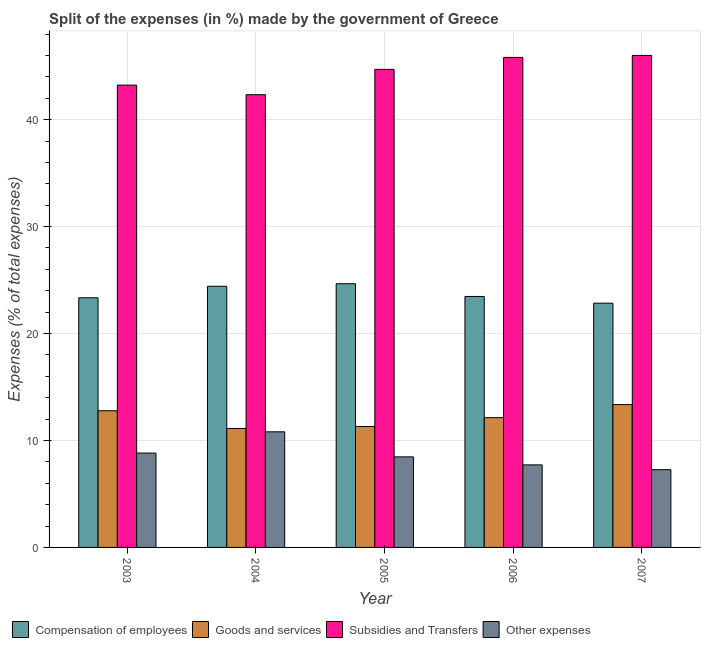How many different coloured bars are there?
Make the answer very short. 4. How many bars are there on the 5th tick from the left?
Make the answer very short. 4. How many bars are there on the 2nd tick from the right?
Offer a terse response. 4. What is the label of the 3rd group of bars from the left?
Your answer should be very brief. 2005. In how many cases, is the number of bars for a given year not equal to the number of legend labels?
Your answer should be compact. 0. What is the percentage of amount spent on goods and services in 2004?
Offer a very short reply. 11.12. Across all years, what is the maximum percentage of amount spent on compensation of employees?
Your answer should be very brief. 24.66. Across all years, what is the minimum percentage of amount spent on subsidies?
Ensure brevity in your answer.  42.33. What is the total percentage of amount spent on goods and services in the graph?
Offer a terse response. 60.7. What is the difference between the percentage of amount spent on goods and services in 2006 and that in 2007?
Provide a succinct answer. -1.22. What is the difference between the percentage of amount spent on other expenses in 2004 and the percentage of amount spent on subsidies in 2006?
Your answer should be compact. 3.09. What is the average percentage of amount spent on subsidies per year?
Offer a terse response. 44.42. In the year 2006, what is the difference between the percentage of amount spent on compensation of employees and percentage of amount spent on other expenses?
Provide a short and direct response. 0. In how many years, is the percentage of amount spent on other expenses greater than 18 %?
Your response must be concise. 0. What is the ratio of the percentage of amount spent on subsidies in 2003 to that in 2004?
Your answer should be very brief. 1.02. What is the difference between the highest and the second highest percentage of amount spent on other expenses?
Provide a succinct answer. 1.99. What is the difference between the highest and the lowest percentage of amount spent on goods and services?
Your response must be concise. 2.23. In how many years, is the percentage of amount spent on compensation of employees greater than the average percentage of amount spent on compensation of employees taken over all years?
Offer a terse response. 2. Is the sum of the percentage of amount spent on subsidies in 2006 and 2007 greater than the maximum percentage of amount spent on other expenses across all years?
Offer a terse response. Yes. Is it the case that in every year, the sum of the percentage of amount spent on goods and services and percentage of amount spent on compensation of employees is greater than the sum of percentage of amount spent on other expenses and percentage of amount spent on subsidies?
Your response must be concise. No. What does the 2nd bar from the left in 2006 represents?
Provide a short and direct response. Goods and services. What does the 3rd bar from the right in 2004 represents?
Your answer should be very brief. Goods and services. Is it the case that in every year, the sum of the percentage of amount spent on compensation of employees and percentage of amount spent on goods and services is greater than the percentage of amount spent on subsidies?
Give a very brief answer. No. How many bars are there?
Your answer should be very brief. 20. Are the values on the major ticks of Y-axis written in scientific E-notation?
Your response must be concise. No. Does the graph contain any zero values?
Give a very brief answer. No. How many legend labels are there?
Provide a short and direct response. 4. How are the legend labels stacked?
Your response must be concise. Horizontal. What is the title of the graph?
Provide a short and direct response. Split of the expenses (in %) made by the government of Greece. Does "HFC gas" appear as one of the legend labels in the graph?
Your answer should be very brief. No. What is the label or title of the X-axis?
Give a very brief answer. Year. What is the label or title of the Y-axis?
Make the answer very short. Expenses (% of total expenses). What is the Expenses (% of total expenses) of Compensation of employees in 2003?
Provide a short and direct response. 23.34. What is the Expenses (% of total expenses) in Goods and services in 2003?
Keep it short and to the point. 12.78. What is the Expenses (% of total expenses) in Subsidies and Transfers in 2003?
Your answer should be very brief. 43.23. What is the Expenses (% of total expenses) of Other expenses in 2003?
Provide a succinct answer. 8.82. What is the Expenses (% of total expenses) in Compensation of employees in 2004?
Your response must be concise. 24.42. What is the Expenses (% of total expenses) in Goods and services in 2004?
Make the answer very short. 11.12. What is the Expenses (% of total expenses) in Subsidies and Transfers in 2004?
Keep it short and to the point. 42.33. What is the Expenses (% of total expenses) of Other expenses in 2004?
Provide a succinct answer. 10.81. What is the Expenses (% of total expenses) of Compensation of employees in 2005?
Your answer should be very brief. 24.66. What is the Expenses (% of total expenses) of Goods and services in 2005?
Provide a succinct answer. 11.31. What is the Expenses (% of total expenses) of Subsidies and Transfers in 2005?
Keep it short and to the point. 44.7. What is the Expenses (% of total expenses) in Other expenses in 2005?
Make the answer very short. 8.47. What is the Expenses (% of total expenses) of Compensation of employees in 2006?
Your response must be concise. 23.47. What is the Expenses (% of total expenses) in Goods and services in 2006?
Give a very brief answer. 12.13. What is the Expenses (% of total expenses) in Subsidies and Transfers in 2006?
Offer a terse response. 45.82. What is the Expenses (% of total expenses) of Other expenses in 2006?
Provide a short and direct response. 7.72. What is the Expenses (% of total expenses) in Compensation of employees in 2007?
Your response must be concise. 22.84. What is the Expenses (% of total expenses) of Goods and services in 2007?
Offer a terse response. 13.36. What is the Expenses (% of total expenses) of Subsidies and Transfers in 2007?
Ensure brevity in your answer.  46. What is the Expenses (% of total expenses) in Other expenses in 2007?
Offer a very short reply. 7.27. Across all years, what is the maximum Expenses (% of total expenses) of Compensation of employees?
Keep it short and to the point. 24.66. Across all years, what is the maximum Expenses (% of total expenses) of Goods and services?
Provide a succinct answer. 13.36. Across all years, what is the maximum Expenses (% of total expenses) in Subsidies and Transfers?
Keep it short and to the point. 46. Across all years, what is the maximum Expenses (% of total expenses) in Other expenses?
Offer a very short reply. 10.81. Across all years, what is the minimum Expenses (% of total expenses) in Compensation of employees?
Provide a short and direct response. 22.84. Across all years, what is the minimum Expenses (% of total expenses) in Goods and services?
Your answer should be compact. 11.12. Across all years, what is the minimum Expenses (% of total expenses) of Subsidies and Transfers?
Provide a succinct answer. 42.33. Across all years, what is the minimum Expenses (% of total expenses) of Other expenses?
Ensure brevity in your answer.  7.27. What is the total Expenses (% of total expenses) of Compensation of employees in the graph?
Provide a short and direct response. 118.73. What is the total Expenses (% of total expenses) in Goods and services in the graph?
Provide a short and direct response. 60.7. What is the total Expenses (% of total expenses) in Subsidies and Transfers in the graph?
Provide a succinct answer. 222.09. What is the total Expenses (% of total expenses) of Other expenses in the graph?
Your answer should be very brief. 43.09. What is the difference between the Expenses (% of total expenses) of Compensation of employees in 2003 and that in 2004?
Give a very brief answer. -1.08. What is the difference between the Expenses (% of total expenses) of Goods and services in 2003 and that in 2004?
Give a very brief answer. 1.66. What is the difference between the Expenses (% of total expenses) of Subsidies and Transfers in 2003 and that in 2004?
Your answer should be very brief. 0.9. What is the difference between the Expenses (% of total expenses) of Other expenses in 2003 and that in 2004?
Offer a terse response. -1.99. What is the difference between the Expenses (% of total expenses) in Compensation of employees in 2003 and that in 2005?
Keep it short and to the point. -1.31. What is the difference between the Expenses (% of total expenses) in Goods and services in 2003 and that in 2005?
Give a very brief answer. 1.47. What is the difference between the Expenses (% of total expenses) of Subsidies and Transfers in 2003 and that in 2005?
Your response must be concise. -1.47. What is the difference between the Expenses (% of total expenses) of Other expenses in 2003 and that in 2005?
Ensure brevity in your answer.  0.35. What is the difference between the Expenses (% of total expenses) in Compensation of employees in 2003 and that in 2006?
Offer a very short reply. -0.12. What is the difference between the Expenses (% of total expenses) in Goods and services in 2003 and that in 2006?
Make the answer very short. 0.65. What is the difference between the Expenses (% of total expenses) of Subsidies and Transfers in 2003 and that in 2006?
Your answer should be compact. -2.59. What is the difference between the Expenses (% of total expenses) of Other expenses in 2003 and that in 2006?
Give a very brief answer. 1.1. What is the difference between the Expenses (% of total expenses) of Compensation of employees in 2003 and that in 2007?
Make the answer very short. 0.5. What is the difference between the Expenses (% of total expenses) in Goods and services in 2003 and that in 2007?
Provide a succinct answer. -0.58. What is the difference between the Expenses (% of total expenses) in Subsidies and Transfers in 2003 and that in 2007?
Ensure brevity in your answer.  -2.78. What is the difference between the Expenses (% of total expenses) of Other expenses in 2003 and that in 2007?
Your response must be concise. 1.55. What is the difference between the Expenses (% of total expenses) in Compensation of employees in 2004 and that in 2005?
Your response must be concise. -0.24. What is the difference between the Expenses (% of total expenses) in Goods and services in 2004 and that in 2005?
Make the answer very short. -0.18. What is the difference between the Expenses (% of total expenses) in Subsidies and Transfers in 2004 and that in 2005?
Give a very brief answer. -2.37. What is the difference between the Expenses (% of total expenses) of Other expenses in 2004 and that in 2005?
Keep it short and to the point. 2.34. What is the difference between the Expenses (% of total expenses) of Compensation of employees in 2004 and that in 2006?
Offer a very short reply. 0.95. What is the difference between the Expenses (% of total expenses) in Goods and services in 2004 and that in 2006?
Offer a very short reply. -1.01. What is the difference between the Expenses (% of total expenses) of Subsidies and Transfers in 2004 and that in 2006?
Keep it short and to the point. -3.49. What is the difference between the Expenses (% of total expenses) in Other expenses in 2004 and that in 2006?
Give a very brief answer. 3.09. What is the difference between the Expenses (% of total expenses) of Compensation of employees in 2004 and that in 2007?
Your response must be concise. 1.58. What is the difference between the Expenses (% of total expenses) in Goods and services in 2004 and that in 2007?
Your response must be concise. -2.23. What is the difference between the Expenses (% of total expenses) of Subsidies and Transfers in 2004 and that in 2007?
Make the answer very short. -3.67. What is the difference between the Expenses (% of total expenses) of Other expenses in 2004 and that in 2007?
Offer a very short reply. 3.54. What is the difference between the Expenses (% of total expenses) of Compensation of employees in 2005 and that in 2006?
Keep it short and to the point. 1.19. What is the difference between the Expenses (% of total expenses) in Goods and services in 2005 and that in 2006?
Provide a short and direct response. -0.83. What is the difference between the Expenses (% of total expenses) in Subsidies and Transfers in 2005 and that in 2006?
Your answer should be very brief. -1.12. What is the difference between the Expenses (% of total expenses) in Other expenses in 2005 and that in 2006?
Your response must be concise. 0.75. What is the difference between the Expenses (% of total expenses) in Compensation of employees in 2005 and that in 2007?
Your answer should be very brief. 1.82. What is the difference between the Expenses (% of total expenses) of Goods and services in 2005 and that in 2007?
Your response must be concise. -2.05. What is the difference between the Expenses (% of total expenses) in Subsidies and Transfers in 2005 and that in 2007?
Offer a very short reply. -1.3. What is the difference between the Expenses (% of total expenses) of Other expenses in 2005 and that in 2007?
Your answer should be compact. 1.2. What is the difference between the Expenses (% of total expenses) in Compensation of employees in 2006 and that in 2007?
Give a very brief answer. 0.63. What is the difference between the Expenses (% of total expenses) of Goods and services in 2006 and that in 2007?
Provide a succinct answer. -1.22. What is the difference between the Expenses (% of total expenses) in Subsidies and Transfers in 2006 and that in 2007?
Ensure brevity in your answer.  -0.19. What is the difference between the Expenses (% of total expenses) of Other expenses in 2006 and that in 2007?
Make the answer very short. 0.45. What is the difference between the Expenses (% of total expenses) of Compensation of employees in 2003 and the Expenses (% of total expenses) of Goods and services in 2004?
Offer a very short reply. 12.22. What is the difference between the Expenses (% of total expenses) of Compensation of employees in 2003 and the Expenses (% of total expenses) of Subsidies and Transfers in 2004?
Give a very brief answer. -18.99. What is the difference between the Expenses (% of total expenses) in Compensation of employees in 2003 and the Expenses (% of total expenses) in Other expenses in 2004?
Offer a very short reply. 12.53. What is the difference between the Expenses (% of total expenses) in Goods and services in 2003 and the Expenses (% of total expenses) in Subsidies and Transfers in 2004?
Offer a terse response. -29.55. What is the difference between the Expenses (% of total expenses) of Goods and services in 2003 and the Expenses (% of total expenses) of Other expenses in 2004?
Your response must be concise. 1.97. What is the difference between the Expenses (% of total expenses) in Subsidies and Transfers in 2003 and the Expenses (% of total expenses) in Other expenses in 2004?
Your answer should be very brief. 32.42. What is the difference between the Expenses (% of total expenses) in Compensation of employees in 2003 and the Expenses (% of total expenses) in Goods and services in 2005?
Provide a short and direct response. 12.04. What is the difference between the Expenses (% of total expenses) of Compensation of employees in 2003 and the Expenses (% of total expenses) of Subsidies and Transfers in 2005?
Your answer should be compact. -21.36. What is the difference between the Expenses (% of total expenses) of Compensation of employees in 2003 and the Expenses (% of total expenses) of Other expenses in 2005?
Make the answer very short. 14.88. What is the difference between the Expenses (% of total expenses) in Goods and services in 2003 and the Expenses (% of total expenses) in Subsidies and Transfers in 2005?
Offer a very short reply. -31.92. What is the difference between the Expenses (% of total expenses) of Goods and services in 2003 and the Expenses (% of total expenses) of Other expenses in 2005?
Give a very brief answer. 4.31. What is the difference between the Expenses (% of total expenses) of Subsidies and Transfers in 2003 and the Expenses (% of total expenses) of Other expenses in 2005?
Make the answer very short. 34.76. What is the difference between the Expenses (% of total expenses) in Compensation of employees in 2003 and the Expenses (% of total expenses) in Goods and services in 2006?
Ensure brevity in your answer.  11.21. What is the difference between the Expenses (% of total expenses) in Compensation of employees in 2003 and the Expenses (% of total expenses) in Subsidies and Transfers in 2006?
Make the answer very short. -22.48. What is the difference between the Expenses (% of total expenses) in Compensation of employees in 2003 and the Expenses (% of total expenses) in Other expenses in 2006?
Provide a succinct answer. 15.62. What is the difference between the Expenses (% of total expenses) in Goods and services in 2003 and the Expenses (% of total expenses) in Subsidies and Transfers in 2006?
Offer a very short reply. -33.04. What is the difference between the Expenses (% of total expenses) in Goods and services in 2003 and the Expenses (% of total expenses) in Other expenses in 2006?
Your answer should be compact. 5.06. What is the difference between the Expenses (% of total expenses) in Subsidies and Transfers in 2003 and the Expenses (% of total expenses) in Other expenses in 2006?
Your response must be concise. 35.51. What is the difference between the Expenses (% of total expenses) in Compensation of employees in 2003 and the Expenses (% of total expenses) in Goods and services in 2007?
Offer a terse response. 9.99. What is the difference between the Expenses (% of total expenses) in Compensation of employees in 2003 and the Expenses (% of total expenses) in Subsidies and Transfers in 2007?
Ensure brevity in your answer.  -22.66. What is the difference between the Expenses (% of total expenses) in Compensation of employees in 2003 and the Expenses (% of total expenses) in Other expenses in 2007?
Your answer should be compact. 16.07. What is the difference between the Expenses (% of total expenses) of Goods and services in 2003 and the Expenses (% of total expenses) of Subsidies and Transfers in 2007?
Offer a terse response. -33.23. What is the difference between the Expenses (% of total expenses) of Goods and services in 2003 and the Expenses (% of total expenses) of Other expenses in 2007?
Keep it short and to the point. 5.51. What is the difference between the Expenses (% of total expenses) in Subsidies and Transfers in 2003 and the Expenses (% of total expenses) in Other expenses in 2007?
Provide a succinct answer. 35.96. What is the difference between the Expenses (% of total expenses) of Compensation of employees in 2004 and the Expenses (% of total expenses) of Goods and services in 2005?
Make the answer very short. 13.11. What is the difference between the Expenses (% of total expenses) of Compensation of employees in 2004 and the Expenses (% of total expenses) of Subsidies and Transfers in 2005?
Make the answer very short. -20.28. What is the difference between the Expenses (% of total expenses) of Compensation of employees in 2004 and the Expenses (% of total expenses) of Other expenses in 2005?
Keep it short and to the point. 15.95. What is the difference between the Expenses (% of total expenses) of Goods and services in 2004 and the Expenses (% of total expenses) of Subsidies and Transfers in 2005?
Give a very brief answer. -33.58. What is the difference between the Expenses (% of total expenses) of Goods and services in 2004 and the Expenses (% of total expenses) of Other expenses in 2005?
Your answer should be compact. 2.66. What is the difference between the Expenses (% of total expenses) of Subsidies and Transfers in 2004 and the Expenses (% of total expenses) of Other expenses in 2005?
Your answer should be compact. 33.86. What is the difference between the Expenses (% of total expenses) of Compensation of employees in 2004 and the Expenses (% of total expenses) of Goods and services in 2006?
Offer a very short reply. 12.28. What is the difference between the Expenses (% of total expenses) in Compensation of employees in 2004 and the Expenses (% of total expenses) in Subsidies and Transfers in 2006?
Your answer should be compact. -21.4. What is the difference between the Expenses (% of total expenses) of Compensation of employees in 2004 and the Expenses (% of total expenses) of Other expenses in 2006?
Make the answer very short. 16.7. What is the difference between the Expenses (% of total expenses) in Goods and services in 2004 and the Expenses (% of total expenses) in Subsidies and Transfers in 2006?
Your answer should be very brief. -34.69. What is the difference between the Expenses (% of total expenses) of Goods and services in 2004 and the Expenses (% of total expenses) of Other expenses in 2006?
Your response must be concise. 3.41. What is the difference between the Expenses (% of total expenses) of Subsidies and Transfers in 2004 and the Expenses (% of total expenses) of Other expenses in 2006?
Provide a short and direct response. 34.61. What is the difference between the Expenses (% of total expenses) of Compensation of employees in 2004 and the Expenses (% of total expenses) of Goods and services in 2007?
Offer a terse response. 11.06. What is the difference between the Expenses (% of total expenses) in Compensation of employees in 2004 and the Expenses (% of total expenses) in Subsidies and Transfers in 2007?
Give a very brief answer. -21.59. What is the difference between the Expenses (% of total expenses) in Compensation of employees in 2004 and the Expenses (% of total expenses) in Other expenses in 2007?
Your answer should be very brief. 17.15. What is the difference between the Expenses (% of total expenses) in Goods and services in 2004 and the Expenses (% of total expenses) in Subsidies and Transfers in 2007?
Your answer should be compact. -34.88. What is the difference between the Expenses (% of total expenses) in Goods and services in 2004 and the Expenses (% of total expenses) in Other expenses in 2007?
Your response must be concise. 3.85. What is the difference between the Expenses (% of total expenses) of Subsidies and Transfers in 2004 and the Expenses (% of total expenses) of Other expenses in 2007?
Your answer should be very brief. 35.06. What is the difference between the Expenses (% of total expenses) of Compensation of employees in 2005 and the Expenses (% of total expenses) of Goods and services in 2006?
Ensure brevity in your answer.  12.52. What is the difference between the Expenses (% of total expenses) of Compensation of employees in 2005 and the Expenses (% of total expenses) of Subsidies and Transfers in 2006?
Your response must be concise. -21.16. What is the difference between the Expenses (% of total expenses) in Compensation of employees in 2005 and the Expenses (% of total expenses) in Other expenses in 2006?
Keep it short and to the point. 16.94. What is the difference between the Expenses (% of total expenses) of Goods and services in 2005 and the Expenses (% of total expenses) of Subsidies and Transfers in 2006?
Your response must be concise. -34.51. What is the difference between the Expenses (% of total expenses) in Goods and services in 2005 and the Expenses (% of total expenses) in Other expenses in 2006?
Ensure brevity in your answer.  3.59. What is the difference between the Expenses (% of total expenses) of Subsidies and Transfers in 2005 and the Expenses (% of total expenses) of Other expenses in 2006?
Keep it short and to the point. 36.98. What is the difference between the Expenses (% of total expenses) in Compensation of employees in 2005 and the Expenses (% of total expenses) in Goods and services in 2007?
Provide a succinct answer. 11.3. What is the difference between the Expenses (% of total expenses) of Compensation of employees in 2005 and the Expenses (% of total expenses) of Subsidies and Transfers in 2007?
Your answer should be compact. -21.35. What is the difference between the Expenses (% of total expenses) of Compensation of employees in 2005 and the Expenses (% of total expenses) of Other expenses in 2007?
Provide a short and direct response. 17.39. What is the difference between the Expenses (% of total expenses) in Goods and services in 2005 and the Expenses (% of total expenses) in Subsidies and Transfers in 2007?
Your answer should be compact. -34.7. What is the difference between the Expenses (% of total expenses) in Goods and services in 2005 and the Expenses (% of total expenses) in Other expenses in 2007?
Offer a terse response. 4.04. What is the difference between the Expenses (% of total expenses) in Subsidies and Transfers in 2005 and the Expenses (% of total expenses) in Other expenses in 2007?
Give a very brief answer. 37.43. What is the difference between the Expenses (% of total expenses) of Compensation of employees in 2006 and the Expenses (% of total expenses) of Goods and services in 2007?
Give a very brief answer. 10.11. What is the difference between the Expenses (% of total expenses) in Compensation of employees in 2006 and the Expenses (% of total expenses) in Subsidies and Transfers in 2007?
Provide a succinct answer. -22.54. What is the difference between the Expenses (% of total expenses) in Compensation of employees in 2006 and the Expenses (% of total expenses) in Other expenses in 2007?
Your response must be concise. 16.2. What is the difference between the Expenses (% of total expenses) in Goods and services in 2006 and the Expenses (% of total expenses) in Subsidies and Transfers in 2007?
Ensure brevity in your answer.  -33.87. What is the difference between the Expenses (% of total expenses) of Goods and services in 2006 and the Expenses (% of total expenses) of Other expenses in 2007?
Keep it short and to the point. 4.86. What is the difference between the Expenses (% of total expenses) of Subsidies and Transfers in 2006 and the Expenses (% of total expenses) of Other expenses in 2007?
Provide a short and direct response. 38.55. What is the average Expenses (% of total expenses) in Compensation of employees per year?
Offer a terse response. 23.75. What is the average Expenses (% of total expenses) in Goods and services per year?
Your answer should be very brief. 12.14. What is the average Expenses (% of total expenses) in Subsidies and Transfers per year?
Offer a terse response. 44.42. What is the average Expenses (% of total expenses) in Other expenses per year?
Provide a succinct answer. 8.62. In the year 2003, what is the difference between the Expenses (% of total expenses) in Compensation of employees and Expenses (% of total expenses) in Goods and services?
Your answer should be compact. 10.56. In the year 2003, what is the difference between the Expenses (% of total expenses) in Compensation of employees and Expenses (% of total expenses) in Subsidies and Transfers?
Make the answer very short. -19.89. In the year 2003, what is the difference between the Expenses (% of total expenses) in Compensation of employees and Expenses (% of total expenses) in Other expenses?
Offer a terse response. 14.52. In the year 2003, what is the difference between the Expenses (% of total expenses) in Goods and services and Expenses (% of total expenses) in Subsidies and Transfers?
Keep it short and to the point. -30.45. In the year 2003, what is the difference between the Expenses (% of total expenses) in Goods and services and Expenses (% of total expenses) in Other expenses?
Ensure brevity in your answer.  3.96. In the year 2003, what is the difference between the Expenses (% of total expenses) of Subsidies and Transfers and Expenses (% of total expenses) of Other expenses?
Your answer should be very brief. 34.41. In the year 2004, what is the difference between the Expenses (% of total expenses) in Compensation of employees and Expenses (% of total expenses) in Goods and services?
Give a very brief answer. 13.29. In the year 2004, what is the difference between the Expenses (% of total expenses) in Compensation of employees and Expenses (% of total expenses) in Subsidies and Transfers?
Ensure brevity in your answer.  -17.91. In the year 2004, what is the difference between the Expenses (% of total expenses) in Compensation of employees and Expenses (% of total expenses) in Other expenses?
Ensure brevity in your answer.  13.61. In the year 2004, what is the difference between the Expenses (% of total expenses) of Goods and services and Expenses (% of total expenses) of Subsidies and Transfers?
Provide a short and direct response. -31.21. In the year 2004, what is the difference between the Expenses (% of total expenses) of Goods and services and Expenses (% of total expenses) of Other expenses?
Your answer should be very brief. 0.31. In the year 2004, what is the difference between the Expenses (% of total expenses) of Subsidies and Transfers and Expenses (% of total expenses) of Other expenses?
Your response must be concise. 31.52. In the year 2005, what is the difference between the Expenses (% of total expenses) in Compensation of employees and Expenses (% of total expenses) in Goods and services?
Offer a terse response. 13.35. In the year 2005, what is the difference between the Expenses (% of total expenses) in Compensation of employees and Expenses (% of total expenses) in Subsidies and Transfers?
Offer a very short reply. -20.04. In the year 2005, what is the difference between the Expenses (% of total expenses) of Compensation of employees and Expenses (% of total expenses) of Other expenses?
Give a very brief answer. 16.19. In the year 2005, what is the difference between the Expenses (% of total expenses) of Goods and services and Expenses (% of total expenses) of Subsidies and Transfers?
Your answer should be compact. -33.39. In the year 2005, what is the difference between the Expenses (% of total expenses) in Goods and services and Expenses (% of total expenses) in Other expenses?
Provide a short and direct response. 2.84. In the year 2005, what is the difference between the Expenses (% of total expenses) of Subsidies and Transfers and Expenses (% of total expenses) of Other expenses?
Keep it short and to the point. 36.23. In the year 2006, what is the difference between the Expenses (% of total expenses) in Compensation of employees and Expenses (% of total expenses) in Goods and services?
Provide a succinct answer. 11.33. In the year 2006, what is the difference between the Expenses (% of total expenses) of Compensation of employees and Expenses (% of total expenses) of Subsidies and Transfers?
Your answer should be very brief. -22.35. In the year 2006, what is the difference between the Expenses (% of total expenses) in Compensation of employees and Expenses (% of total expenses) in Other expenses?
Offer a very short reply. 15.75. In the year 2006, what is the difference between the Expenses (% of total expenses) of Goods and services and Expenses (% of total expenses) of Subsidies and Transfers?
Provide a short and direct response. -33.68. In the year 2006, what is the difference between the Expenses (% of total expenses) of Goods and services and Expenses (% of total expenses) of Other expenses?
Keep it short and to the point. 4.42. In the year 2006, what is the difference between the Expenses (% of total expenses) of Subsidies and Transfers and Expenses (% of total expenses) of Other expenses?
Give a very brief answer. 38.1. In the year 2007, what is the difference between the Expenses (% of total expenses) of Compensation of employees and Expenses (% of total expenses) of Goods and services?
Provide a succinct answer. 9.48. In the year 2007, what is the difference between the Expenses (% of total expenses) of Compensation of employees and Expenses (% of total expenses) of Subsidies and Transfers?
Your answer should be very brief. -23.16. In the year 2007, what is the difference between the Expenses (% of total expenses) of Compensation of employees and Expenses (% of total expenses) of Other expenses?
Keep it short and to the point. 15.57. In the year 2007, what is the difference between the Expenses (% of total expenses) in Goods and services and Expenses (% of total expenses) in Subsidies and Transfers?
Offer a terse response. -32.65. In the year 2007, what is the difference between the Expenses (% of total expenses) of Goods and services and Expenses (% of total expenses) of Other expenses?
Your answer should be very brief. 6.09. In the year 2007, what is the difference between the Expenses (% of total expenses) of Subsidies and Transfers and Expenses (% of total expenses) of Other expenses?
Offer a terse response. 38.73. What is the ratio of the Expenses (% of total expenses) of Compensation of employees in 2003 to that in 2004?
Ensure brevity in your answer.  0.96. What is the ratio of the Expenses (% of total expenses) of Goods and services in 2003 to that in 2004?
Offer a very short reply. 1.15. What is the ratio of the Expenses (% of total expenses) in Subsidies and Transfers in 2003 to that in 2004?
Your answer should be very brief. 1.02. What is the ratio of the Expenses (% of total expenses) of Other expenses in 2003 to that in 2004?
Provide a short and direct response. 0.82. What is the ratio of the Expenses (% of total expenses) in Compensation of employees in 2003 to that in 2005?
Your answer should be compact. 0.95. What is the ratio of the Expenses (% of total expenses) in Goods and services in 2003 to that in 2005?
Provide a succinct answer. 1.13. What is the ratio of the Expenses (% of total expenses) of Subsidies and Transfers in 2003 to that in 2005?
Provide a short and direct response. 0.97. What is the ratio of the Expenses (% of total expenses) of Other expenses in 2003 to that in 2005?
Offer a terse response. 1.04. What is the ratio of the Expenses (% of total expenses) of Compensation of employees in 2003 to that in 2006?
Your answer should be very brief. 0.99. What is the ratio of the Expenses (% of total expenses) of Goods and services in 2003 to that in 2006?
Make the answer very short. 1.05. What is the ratio of the Expenses (% of total expenses) of Subsidies and Transfers in 2003 to that in 2006?
Provide a succinct answer. 0.94. What is the ratio of the Expenses (% of total expenses) of Other expenses in 2003 to that in 2006?
Your answer should be compact. 1.14. What is the ratio of the Expenses (% of total expenses) of Compensation of employees in 2003 to that in 2007?
Give a very brief answer. 1.02. What is the ratio of the Expenses (% of total expenses) of Goods and services in 2003 to that in 2007?
Provide a succinct answer. 0.96. What is the ratio of the Expenses (% of total expenses) in Subsidies and Transfers in 2003 to that in 2007?
Make the answer very short. 0.94. What is the ratio of the Expenses (% of total expenses) in Other expenses in 2003 to that in 2007?
Offer a terse response. 1.21. What is the ratio of the Expenses (% of total expenses) in Compensation of employees in 2004 to that in 2005?
Ensure brevity in your answer.  0.99. What is the ratio of the Expenses (% of total expenses) of Goods and services in 2004 to that in 2005?
Make the answer very short. 0.98. What is the ratio of the Expenses (% of total expenses) in Subsidies and Transfers in 2004 to that in 2005?
Give a very brief answer. 0.95. What is the ratio of the Expenses (% of total expenses) of Other expenses in 2004 to that in 2005?
Ensure brevity in your answer.  1.28. What is the ratio of the Expenses (% of total expenses) of Compensation of employees in 2004 to that in 2006?
Keep it short and to the point. 1.04. What is the ratio of the Expenses (% of total expenses) in Subsidies and Transfers in 2004 to that in 2006?
Ensure brevity in your answer.  0.92. What is the ratio of the Expenses (% of total expenses) of Other expenses in 2004 to that in 2006?
Your answer should be very brief. 1.4. What is the ratio of the Expenses (% of total expenses) in Compensation of employees in 2004 to that in 2007?
Your response must be concise. 1.07. What is the ratio of the Expenses (% of total expenses) in Goods and services in 2004 to that in 2007?
Give a very brief answer. 0.83. What is the ratio of the Expenses (% of total expenses) of Subsidies and Transfers in 2004 to that in 2007?
Make the answer very short. 0.92. What is the ratio of the Expenses (% of total expenses) in Other expenses in 2004 to that in 2007?
Your answer should be very brief. 1.49. What is the ratio of the Expenses (% of total expenses) in Compensation of employees in 2005 to that in 2006?
Your response must be concise. 1.05. What is the ratio of the Expenses (% of total expenses) in Goods and services in 2005 to that in 2006?
Give a very brief answer. 0.93. What is the ratio of the Expenses (% of total expenses) of Subsidies and Transfers in 2005 to that in 2006?
Your answer should be very brief. 0.98. What is the ratio of the Expenses (% of total expenses) of Other expenses in 2005 to that in 2006?
Your answer should be very brief. 1.1. What is the ratio of the Expenses (% of total expenses) in Compensation of employees in 2005 to that in 2007?
Give a very brief answer. 1.08. What is the ratio of the Expenses (% of total expenses) in Goods and services in 2005 to that in 2007?
Keep it short and to the point. 0.85. What is the ratio of the Expenses (% of total expenses) in Subsidies and Transfers in 2005 to that in 2007?
Your answer should be compact. 0.97. What is the ratio of the Expenses (% of total expenses) of Other expenses in 2005 to that in 2007?
Your answer should be compact. 1.16. What is the ratio of the Expenses (% of total expenses) in Compensation of employees in 2006 to that in 2007?
Offer a terse response. 1.03. What is the ratio of the Expenses (% of total expenses) in Goods and services in 2006 to that in 2007?
Ensure brevity in your answer.  0.91. What is the ratio of the Expenses (% of total expenses) of Other expenses in 2006 to that in 2007?
Make the answer very short. 1.06. What is the difference between the highest and the second highest Expenses (% of total expenses) of Compensation of employees?
Your response must be concise. 0.24. What is the difference between the highest and the second highest Expenses (% of total expenses) in Goods and services?
Give a very brief answer. 0.58. What is the difference between the highest and the second highest Expenses (% of total expenses) of Subsidies and Transfers?
Make the answer very short. 0.19. What is the difference between the highest and the second highest Expenses (% of total expenses) of Other expenses?
Your answer should be compact. 1.99. What is the difference between the highest and the lowest Expenses (% of total expenses) of Compensation of employees?
Make the answer very short. 1.82. What is the difference between the highest and the lowest Expenses (% of total expenses) of Goods and services?
Provide a succinct answer. 2.23. What is the difference between the highest and the lowest Expenses (% of total expenses) of Subsidies and Transfers?
Your response must be concise. 3.67. What is the difference between the highest and the lowest Expenses (% of total expenses) of Other expenses?
Offer a very short reply. 3.54. 